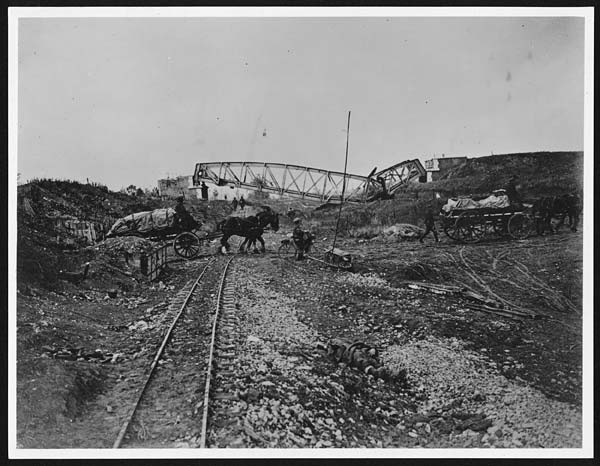What does the image suggest about the time period it was taken in? The image likely dates back to the late 19th or early 20th century. This deduction is based on the black-and-white format, the presence of horse carriages, and the depiction of workers actively engaged in laying down a railroad. These details suggest a time when railways were being expanded and horses were still a primary mode of transportation. The rural setting and absence of modern infrastructure underscore the historical nature of the photo. 